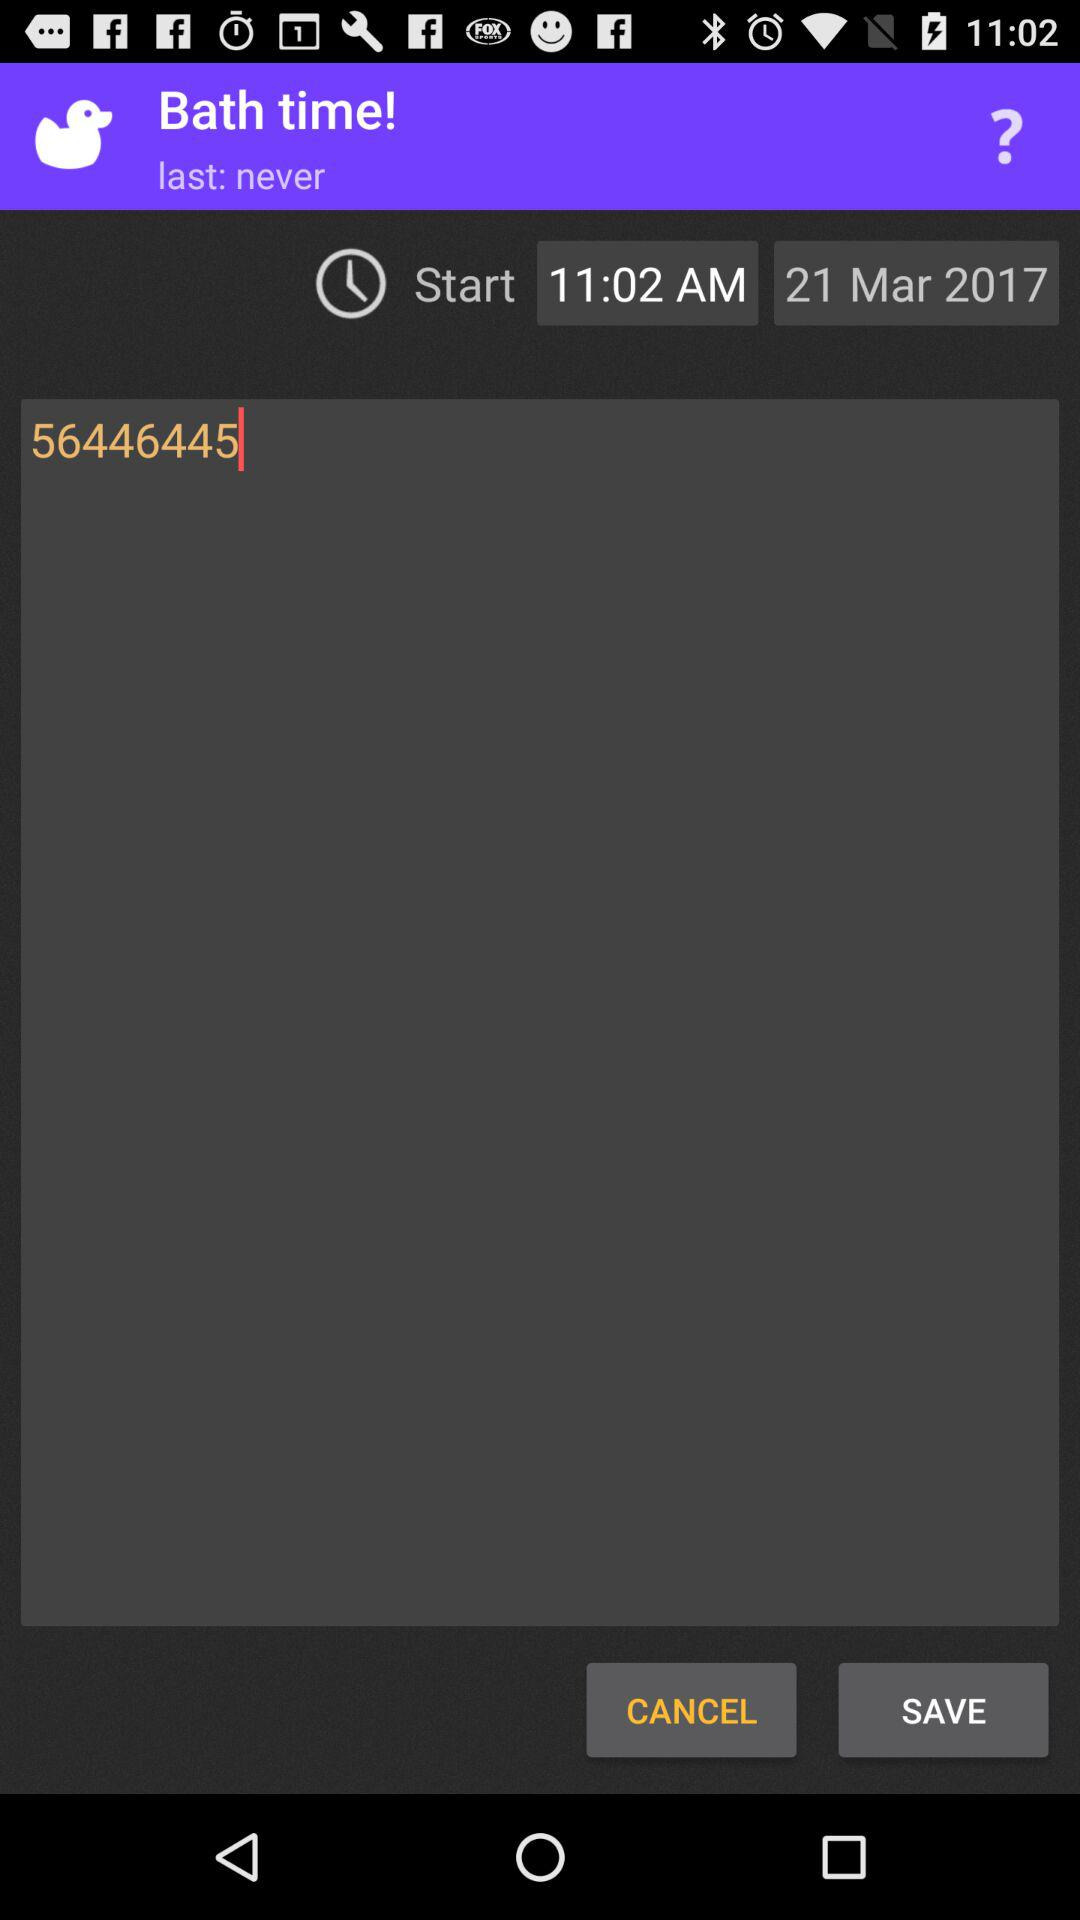What is the date and time of the bath?
Answer the question using a single word or phrase. 21 Mar 2017 11:02 AM 